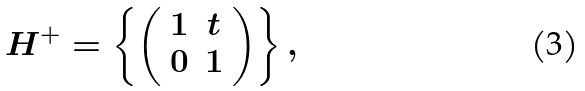Convert formula to latex. <formula><loc_0><loc_0><loc_500><loc_500>H ^ { + } = \left \{ \left ( \begin{array} { c c } 1 & t \\ 0 & 1 \end{array} \right ) \right \} ,</formula> 